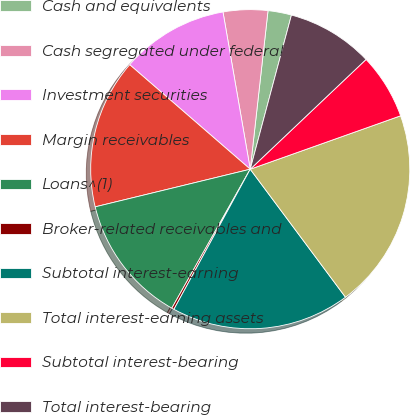<chart> <loc_0><loc_0><loc_500><loc_500><pie_chart><fcel>Cash and equivalents<fcel>Cash segregated under federal<fcel>Investment securities<fcel>Margin receivables<fcel>Loans^(1)<fcel>Broker-related receivables and<fcel>Subtotal interest-earning<fcel>Total interest-earning assets<fcel>Subtotal interest-bearing<fcel>Total interest-bearing<nl><fcel>2.38%<fcel>4.51%<fcel>10.9%<fcel>15.16%<fcel>13.03%<fcel>0.24%<fcel>18.12%<fcel>20.25%<fcel>6.64%<fcel>8.77%<nl></chart> 